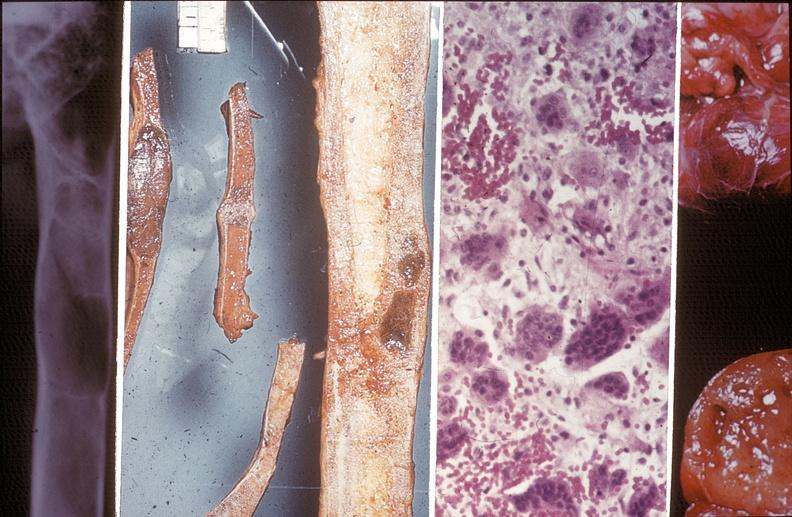what does this image show?
Answer the question using a single word or phrase. Bone 